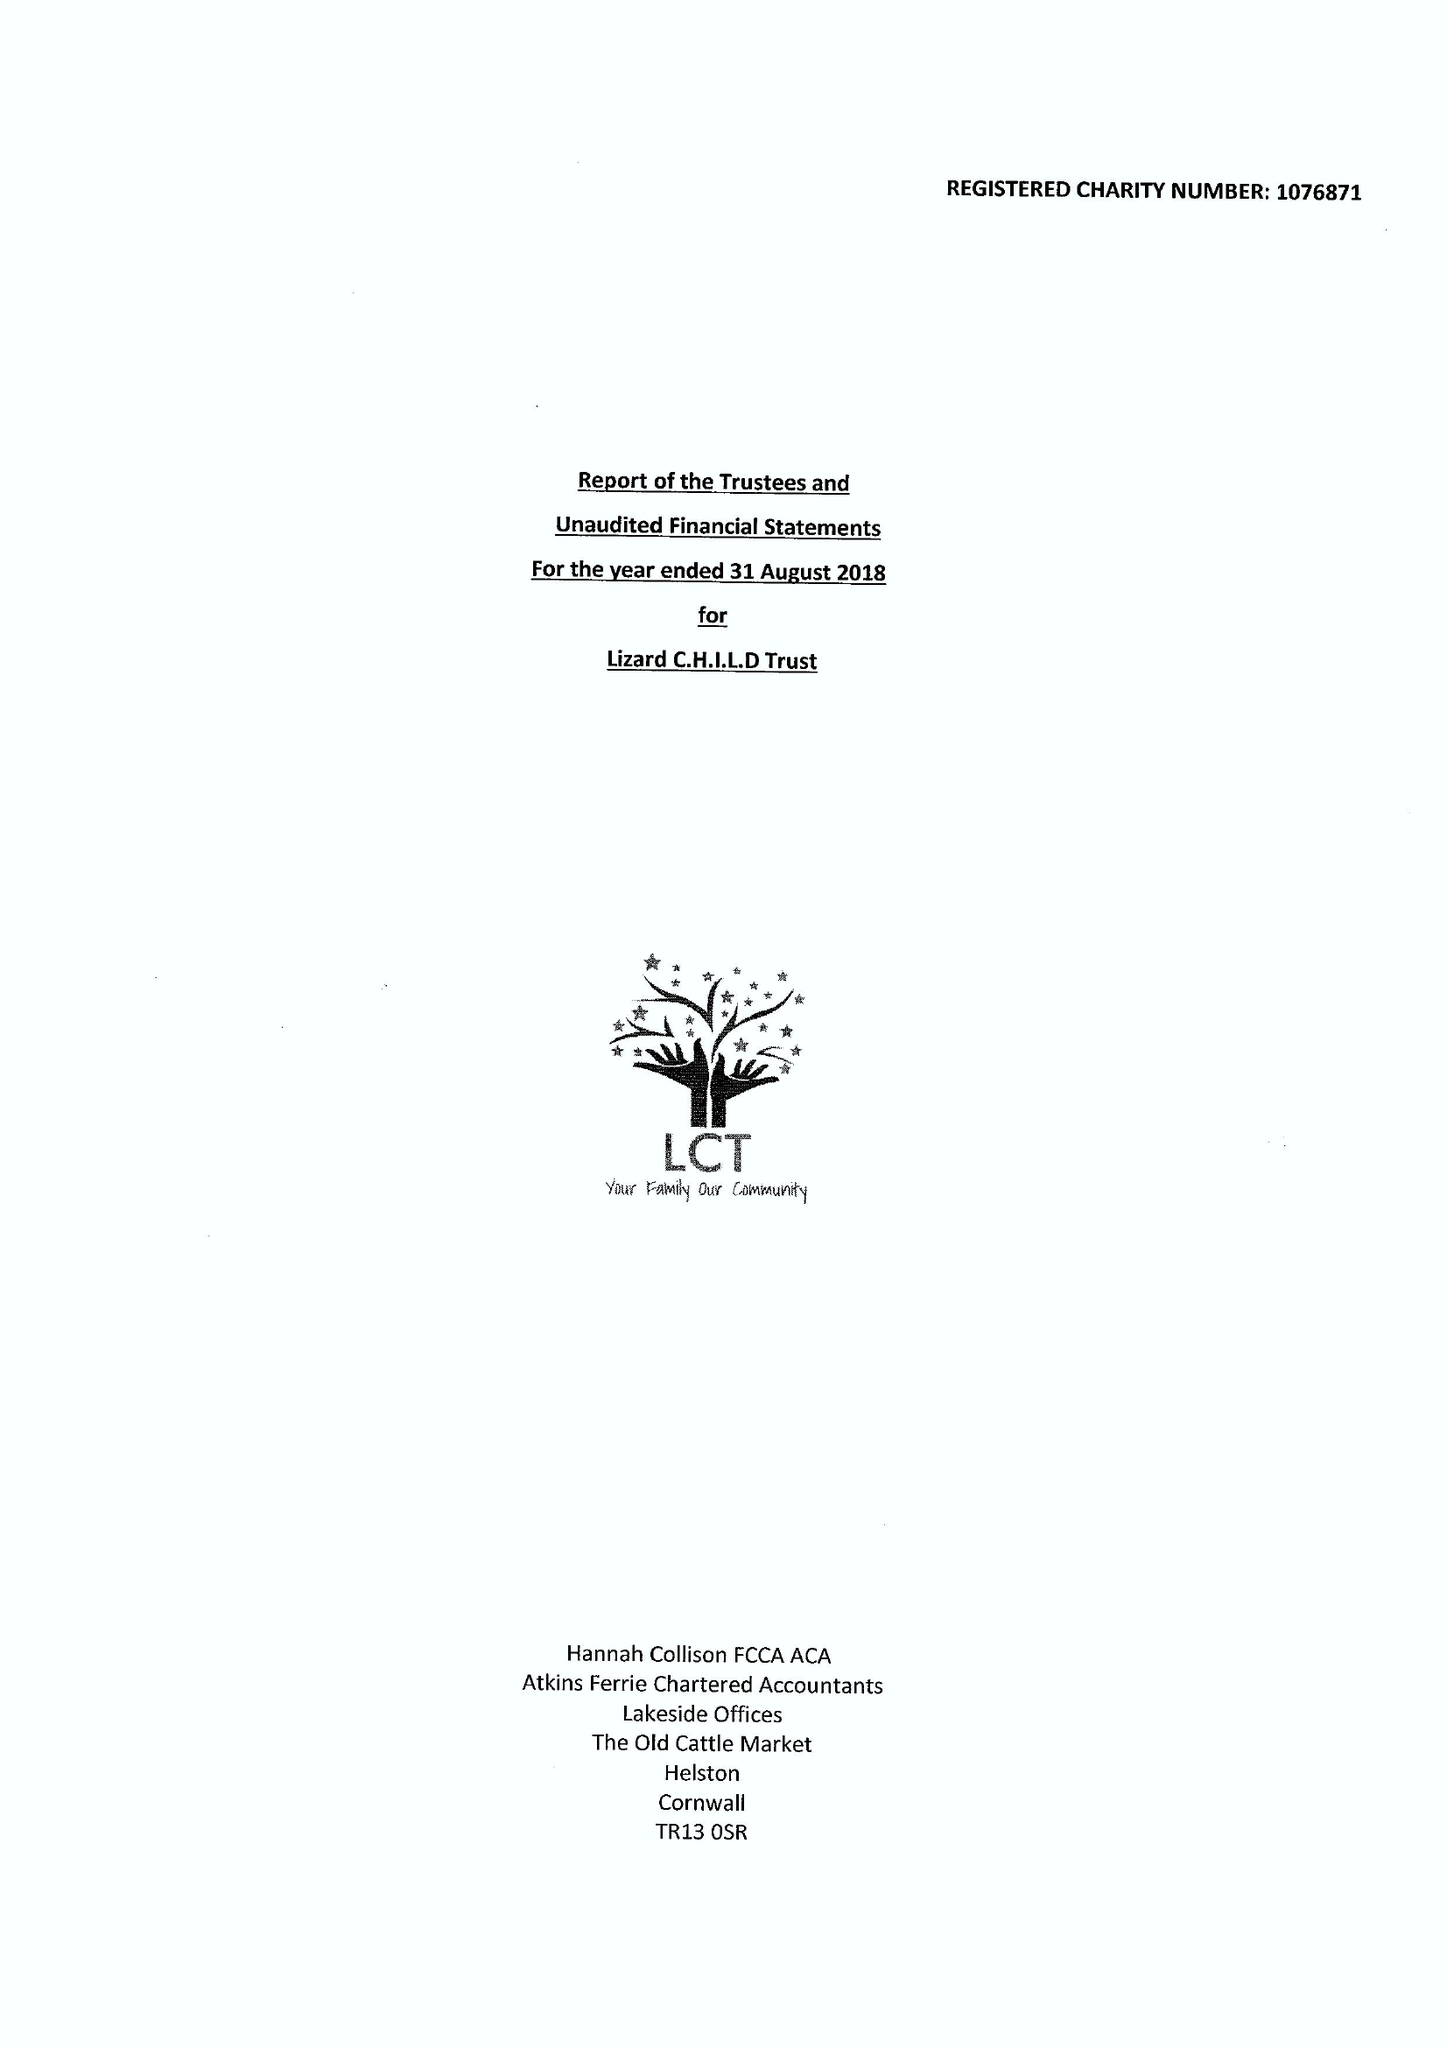What is the value for the charity_name?
Answer the question using a single word or phrase. Lizard C.H.I.L.D. Trust 